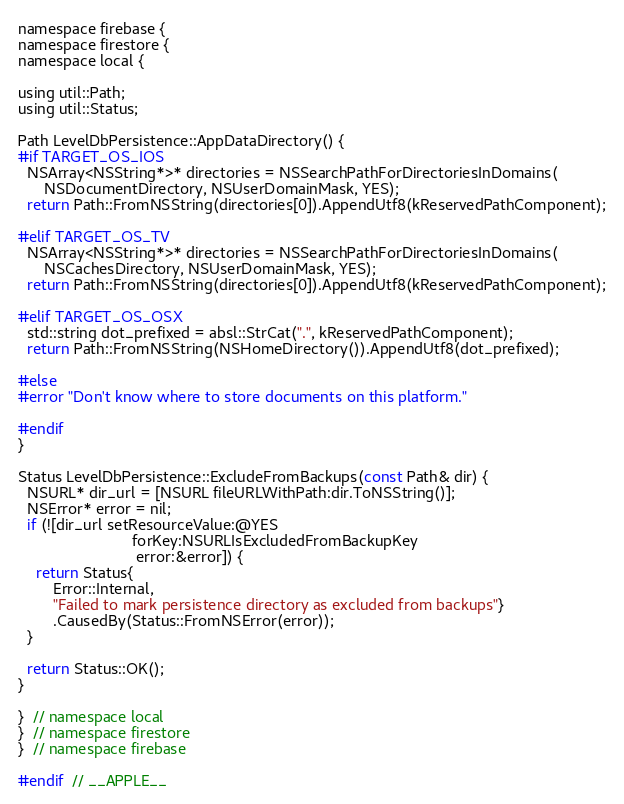Convert code to text. <code><loc_0><loc_0><loc_500><loc_500><_ObjectiveC_>namespace firebase {
namespace firestore {
namespace local {

using util::Path;
using util::Status;

Path LevelDbPersistence::AppDataDirectory() {
#if TARGET_OS_IOS
  NSArray<NSString*>* directories = NSSearchPathForDirectoriesInDomains(
      NSDocumentDirectory, NSUserDomainMask, YES);
  return Path::FromNSString(directories[0]).AppendUtf8(kReservedPathComponent);

#elif TARGET_OS_TV
  NSArray<NSString*>* directories = NSSearchPathForDirectoriesInDomains(
      NSCachesDirectory, NSUserDomainMask, YES);
  return Path::FromNSString(directories[0]).AppendUtf8(kReservedPathComponent);

#elif TARGET_OS_OSX
  std::string dot_prefixed = absl::StrCat(".", kReservedPathComponent);
  return Path::FromNSString(NSHomeDirectory()).AppendUtf8(dot_prefixed);

#else
#error "Don't know where to store documents on this platform."

#endif
}

Status LevelDbPersistence::ExcludeFromBackups(const Path& dir) {
  NSURL* dir_url = [NSURL fileURLWithPath:dir.ToNSString()];
  NSError* error = nil;
  if (![dir_url setResourceValue:@YES
                          forKey:NSURLIsExcludedFromBackupKey
                           error:&error]) {
    return Status{
        Error::Internal,
        "Failed to mark persistence directory as excluded from backups"}
        .CausedBy(Status::FromNSError(error));
  }

  return Status::OK();
}

}  // namespace local
}  // namespace firestore
}  // namespace firebase

#endif  // __APPLE__
</code> 